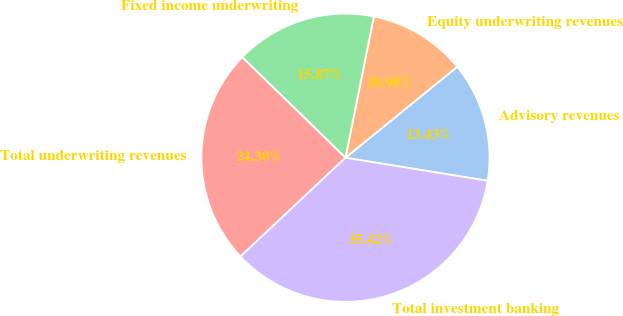<chart> <loc_0><loc_0><loc_500><loc_500><pie_chart><fcel>Advisory revenues<fcel>Equity underwriting revenues<fcel>Fixed income underwriting<fcel>Total underwriting revenues<fcel>Total investment banking<nl><fcel>13.43%<fcel>10.98%<fcel>15.87%<fcel>24.3%<fcel>35.42%<nl></chart> 